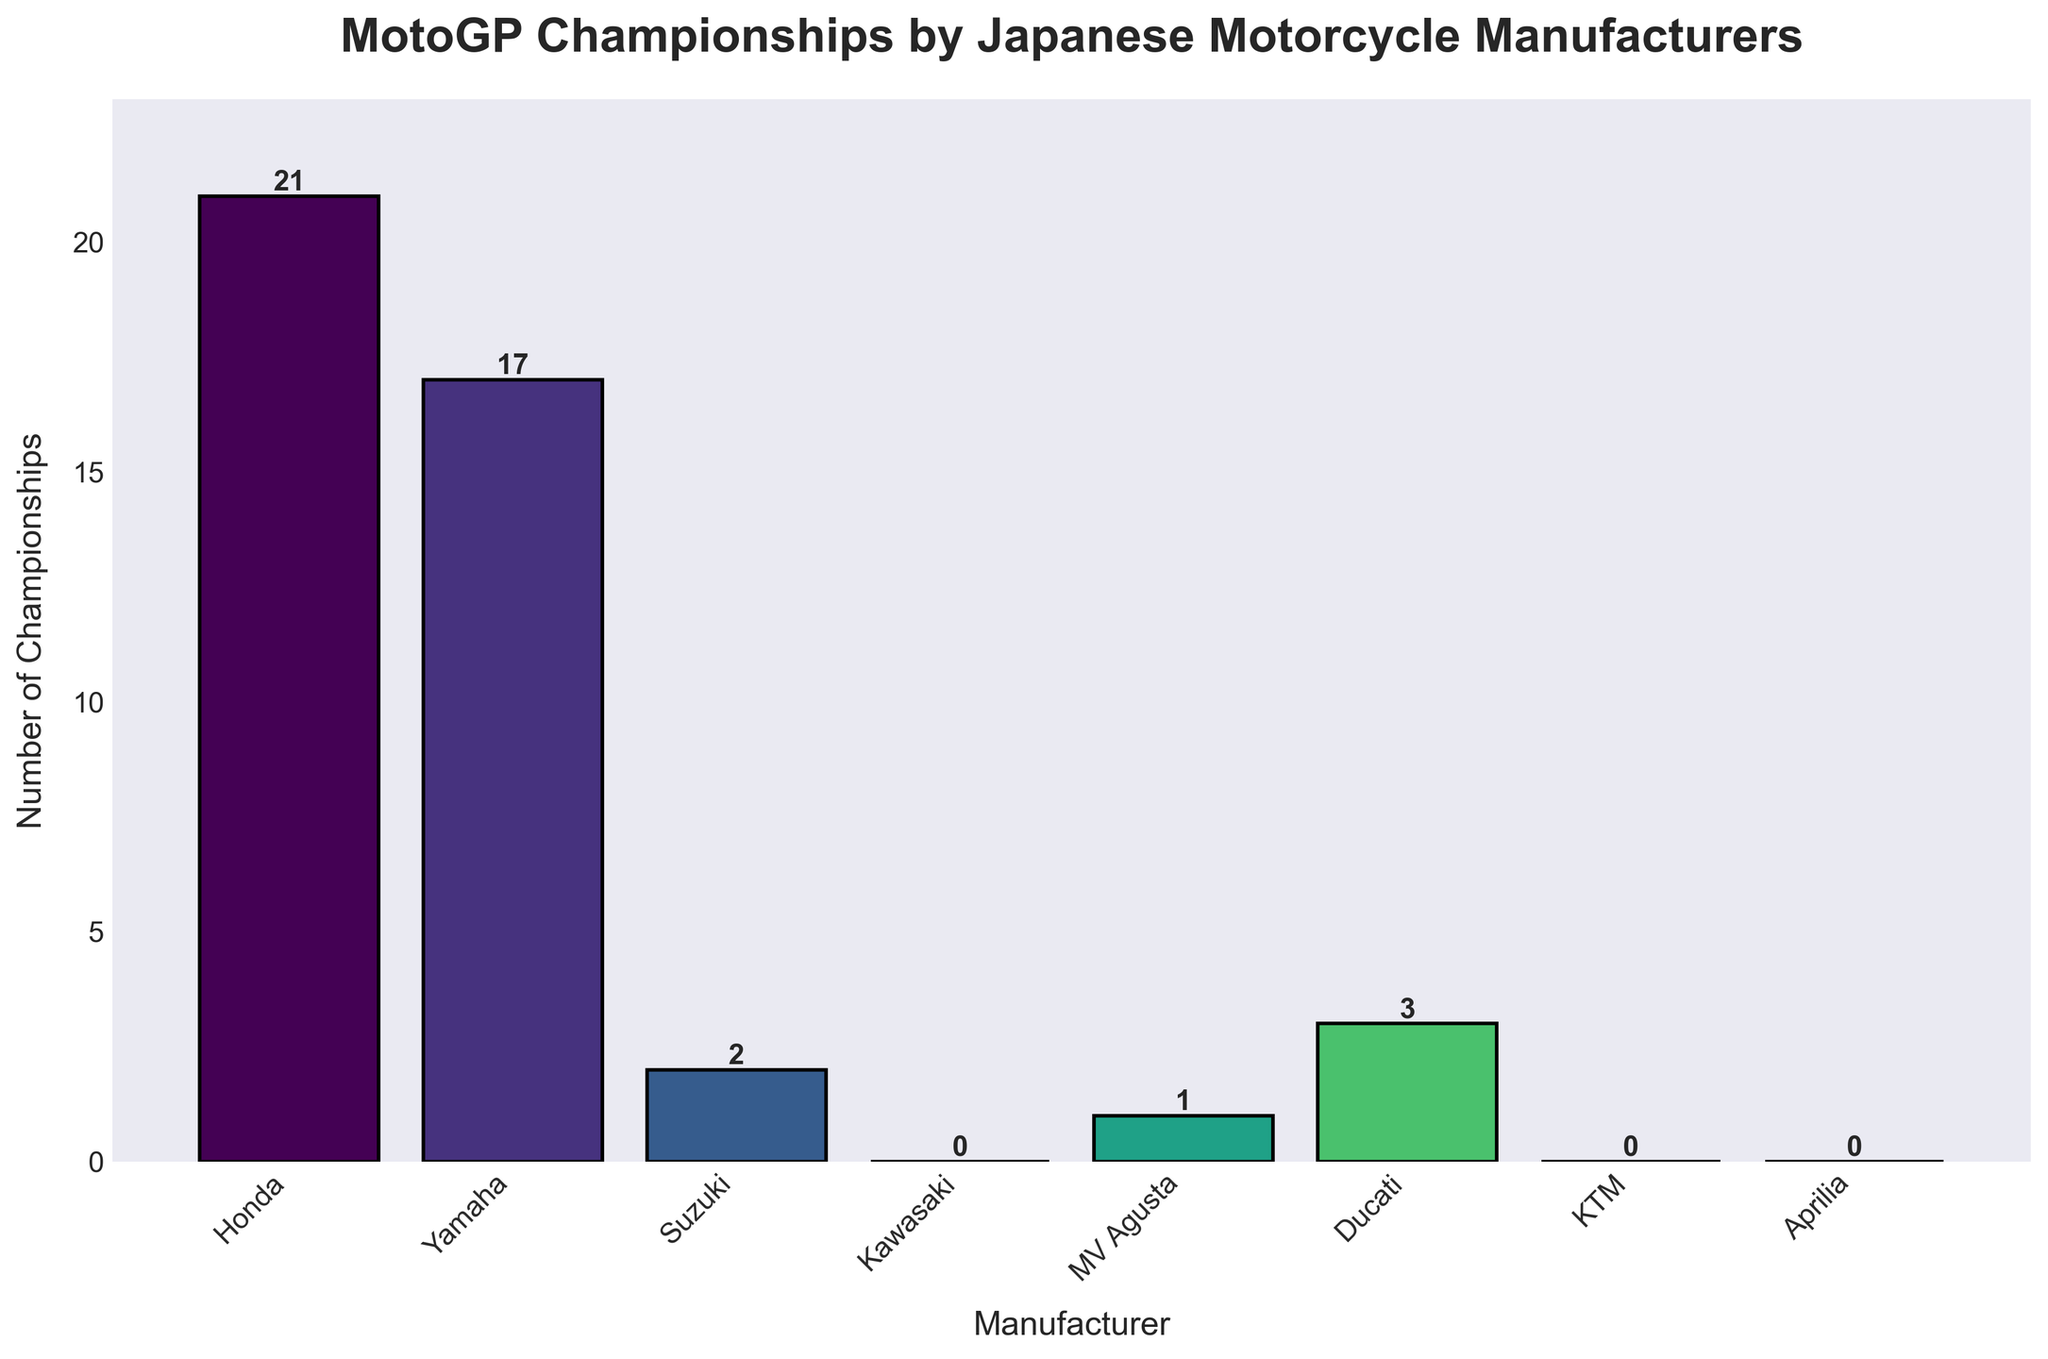Which manufacturer has won the most MotoGP championships? The bar for Honda is the tallest, indicating they have the highest number of MotoGP championships.
Answer: Honda Which manufacturers have won no MotoGP championships? The bars for Kawasaki, KTM, and Aprilia show a height of 0, indicating they haven't won any championships.
Answer: Kawasaki, KTM, Aprilia How many more championships has Honda won compared to Yamaha? Honda has 21 championships and Yamaha has 17. Subtracting gives 21 - 17.
Answer: 4 What is the total number of MotoGP championships won by Yamaha and Ducati combined? Adding the value for Yamaha (17) and Ducati (3) gives 17 + 3.
Answer: 20 Which manufacturer won fewer championships, Suzuki or MV Agusta? The bar for Suzuki is shorter with 2 championships compared to the bar for MV Agusta with 1.
Answer: MV Agusta How many total championships have been won by all Japanese manufacturers? Adding the championships for Honda (21), Yamaha (17), Suzuki (2), and Kawasaki (0) gives 21 + 17 + 2 + 0.
Answer: 40 By how much does Honda's championships exceed the combined total of Suzuki, Kawasaki, KTM, and Aprilia? Honda has 21 championships. The combined total for Suzuki (2), Kawasaki (0), KTM (0), and Aprilia (0) is 2. So 21 - 2.
Answer: 19 Which manufacturer has won exactly two MotoGP championships? The bar for Suzuki has a height of 2, indicating it has won exactly two championships.
Answer: Suzuki How many manufacturers have won more than 10 championships each? The bars for Honda (21) and Yamaha (17) exceed the 10 mark. This counts to two manufacturers.
Answer: 2 If you average the number of championships won by Honda, Yamaha, and Ducati, what value do you get? Adding the championships for Honda (21), Yamaha (17), and Ducati (3) gives 21 + 17 + 3 = 41. Dividing by 3 gives 41/3.
Answer: 13.67 